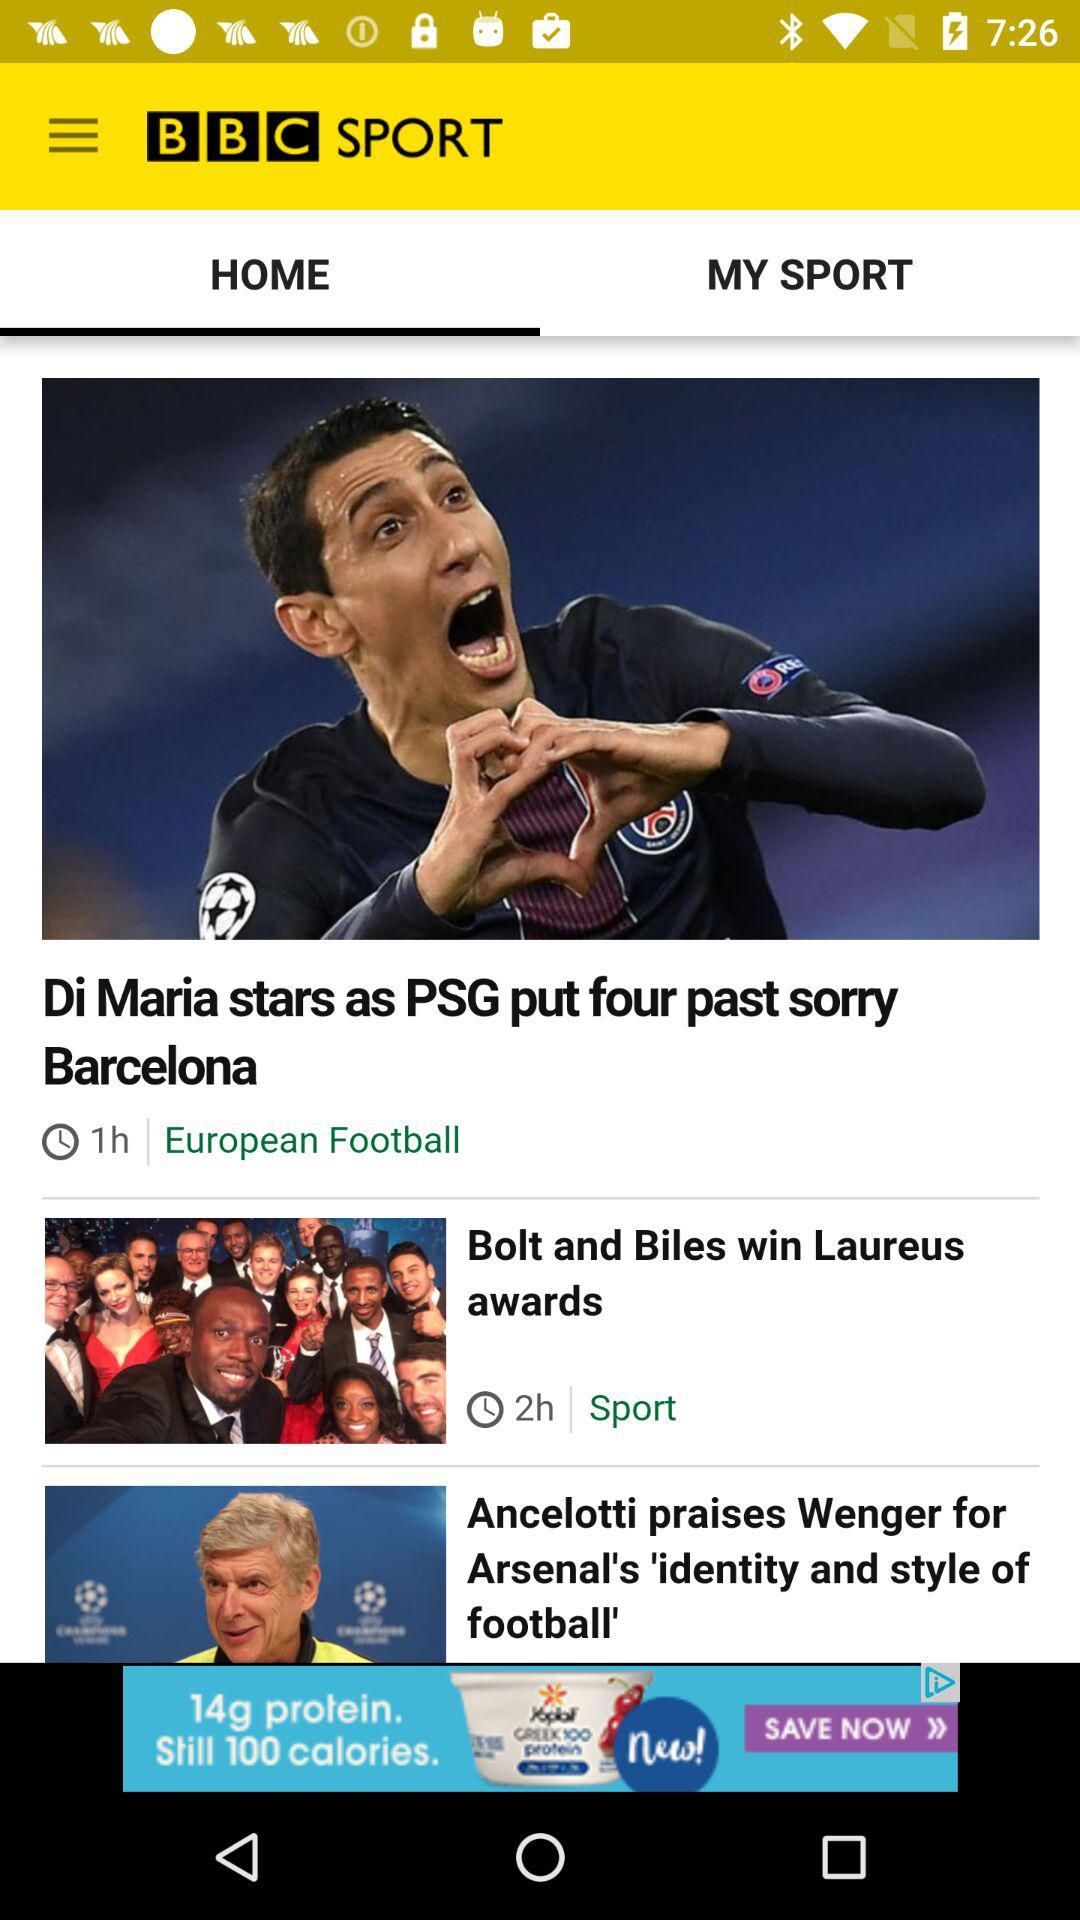What is the title of the news story that was published an hour ago? The title is "Di Maria stars as PSG put four past sorry Barcelona". 